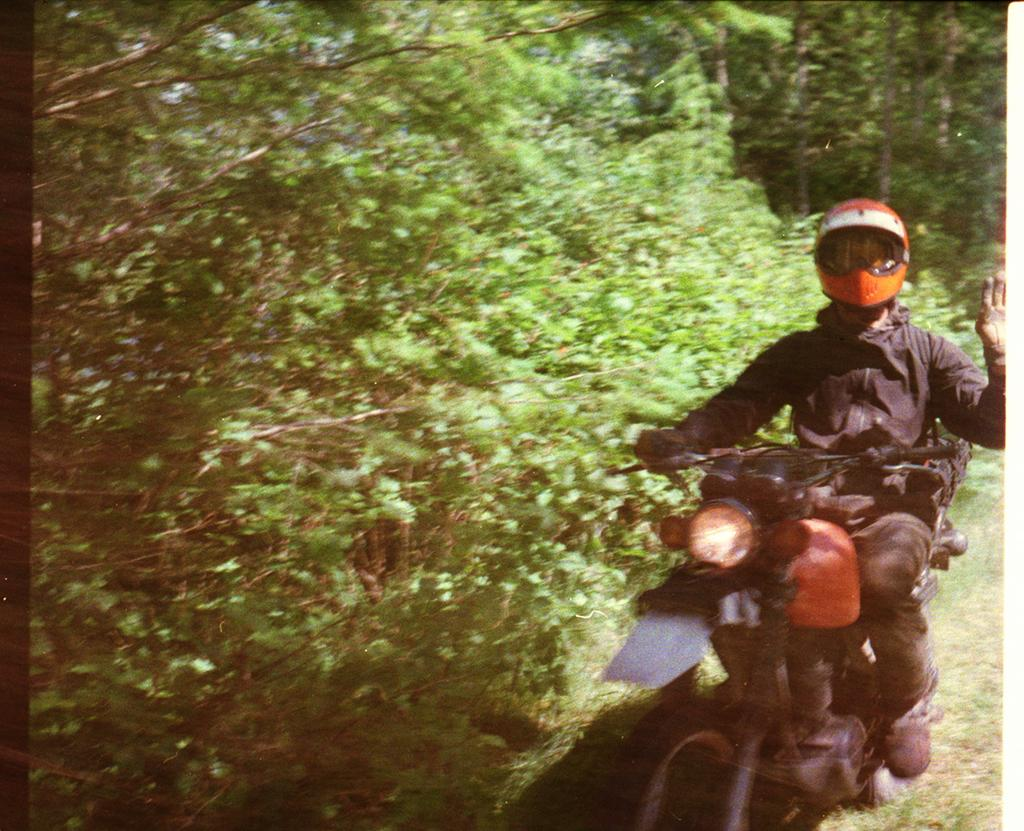Who or what is present in the image? There is a person in the image. What is the person wearing? The person is wearing clothes, a helmet, gloves, and shoes. What activity is the person engaged in? The person is riding a bike. Can you describe the bike? The bike is visible in the image and has a headlight. What type of environment is depicted in the image? There is grass and trees in the image, suggesting a natural setting. What type of pan can be seen hanging from the tree in the image? There is no pan present in the image; it features a person riding a bike in a natural setting with grass and trees. What type of brick structure can be seen in the background of the image? There is no brick structure visible in the image; it only shows a person riding a bike in a natural setting with grass and trees. 